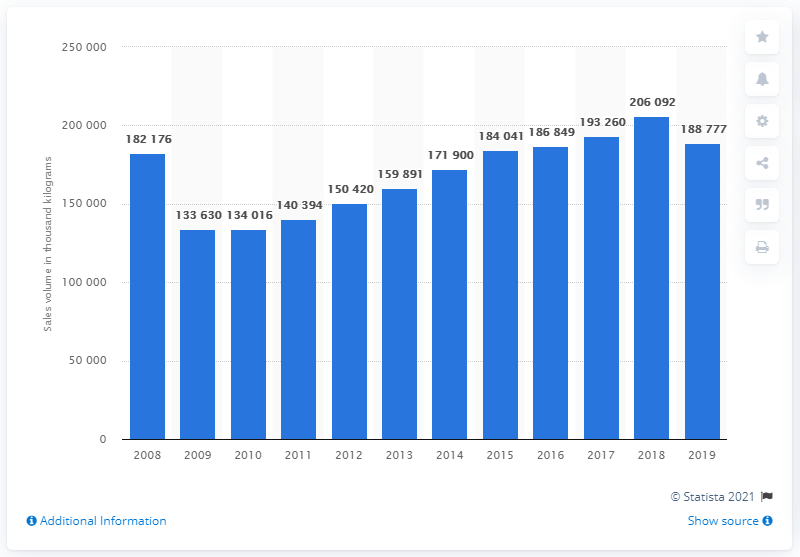Specify some key components in this picture. In 2019, the sales volume of potato chips was 188,777 units. 